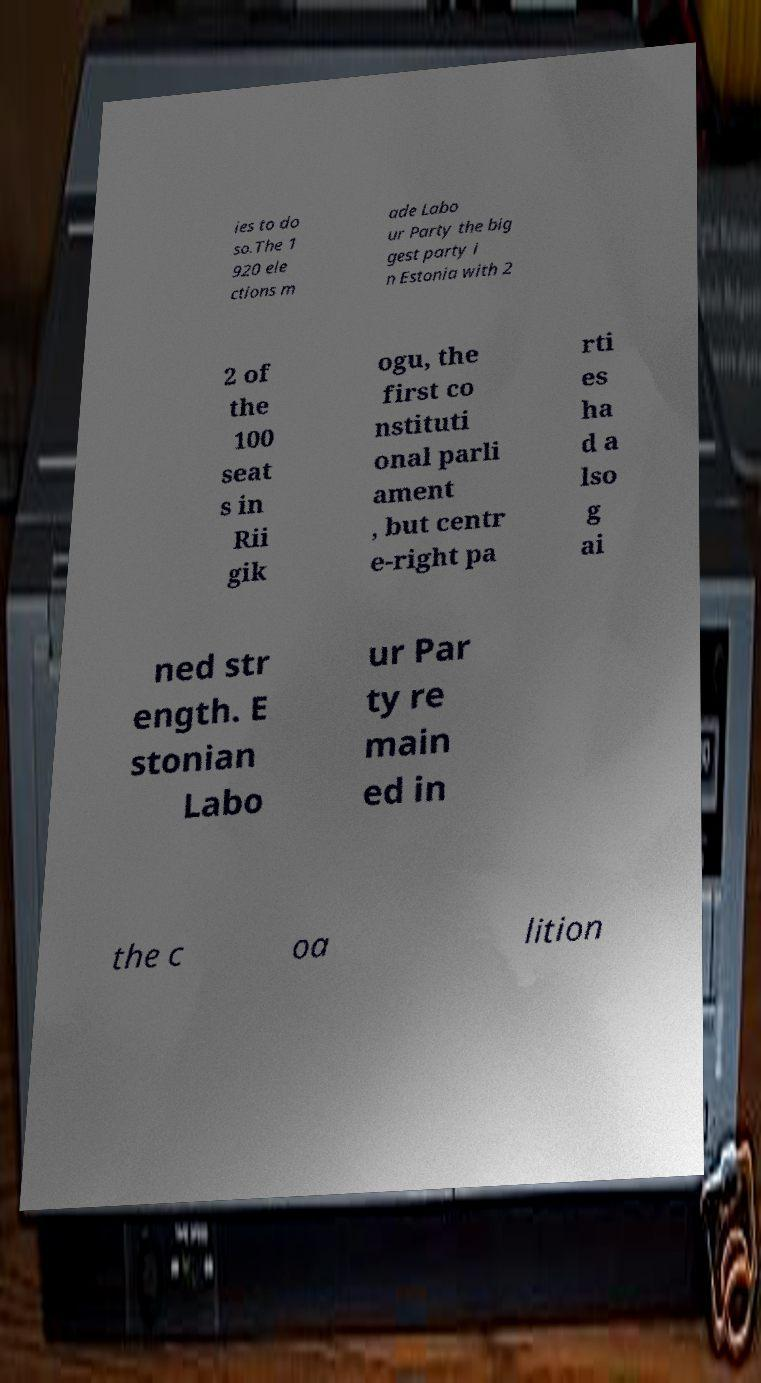Can you accurately transcribe the text from the provided image for me? ies to do so.The 1 920 ele ctions m ade Labo ur Party the big gest party i n Estonia with 2 2 of the 100 seat s in Rii gik ogu, the first co nstituti onal parli ament , but centr e-right pa rti es ha d a lso g ai ned str ength. E stonian Labo ur Par ty re main ed in the c oa lition 